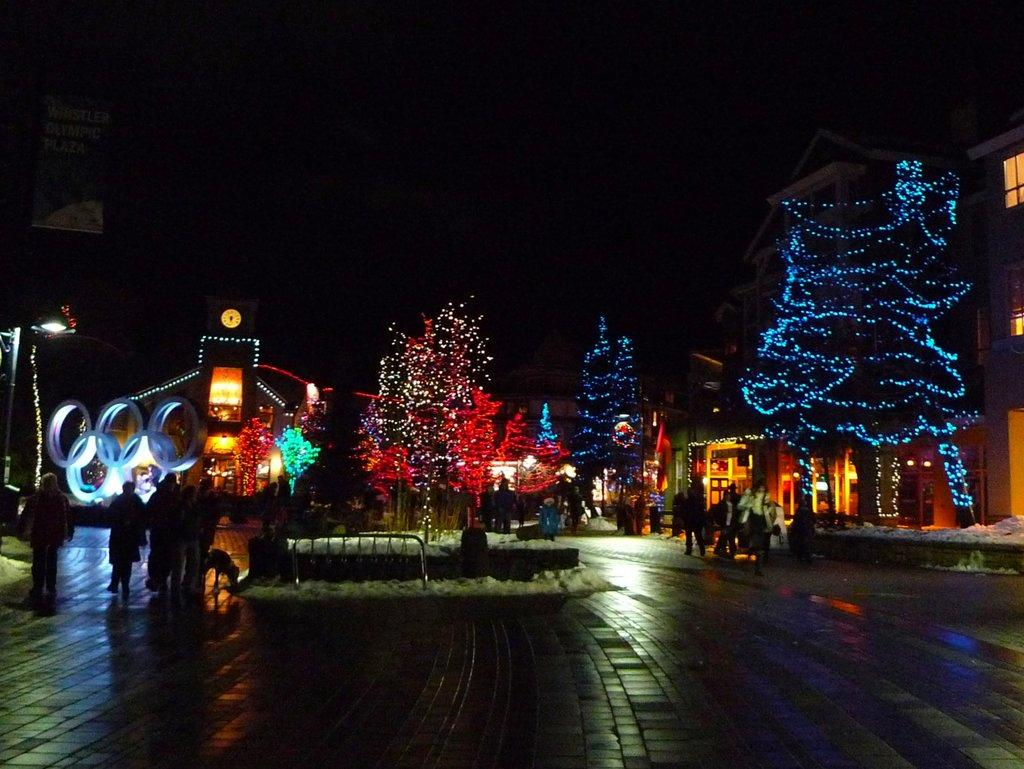What type of decoration is present on the trees in the image? The trees in the image have lights on them. What structure can be seen on the right side of the image? There is a building on the right side of the image. What is visible at the top of the image? The sky is visible at the top of the image. What time of day is it in the image, considering the presence of salt? There is no salt present in the image, and therefore it cannot be used to determine the time of day. 